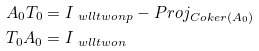<formula> <loc_0><loc_0><loc_500><loc_500>A _ { 0 } T _ { 0 } & = I _ { \ w l l t w o n p } - P r o j _ { C o k e r ( A _ { 0 } ) } \\ T _ { 0 } A _ { 0 } & = I _ { \ w l l t w o n }</formula> 